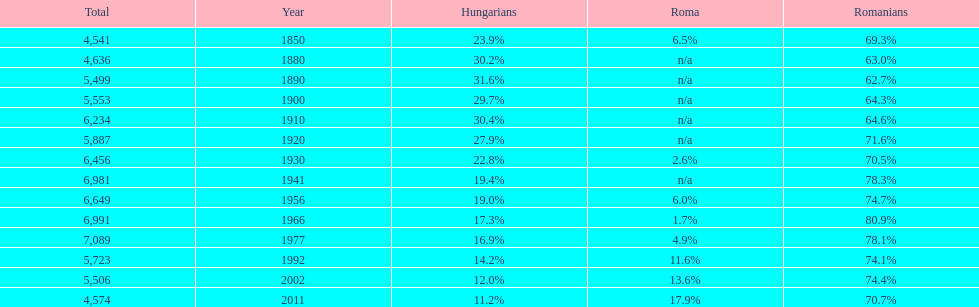Which year is previous to the year that had 74.1% in romanian population? 1977. 